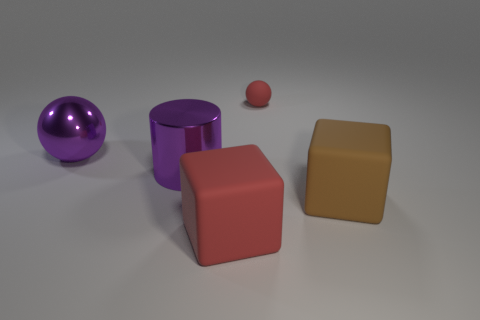Add 4 big purple shiny objects. How many objects exist? 9 Subtract all spheres. How many objects are left? 3 Subtract 1 red spheres. How many objects are left? 4 Subtract all yellow shiny spheres. Subtract all red matte spheres. How many objects are left? 4 Add 5 tiny red objects. How many tiny red objects are left? 6 Add 1 big purple balls. How many big purple balls exist? 2 